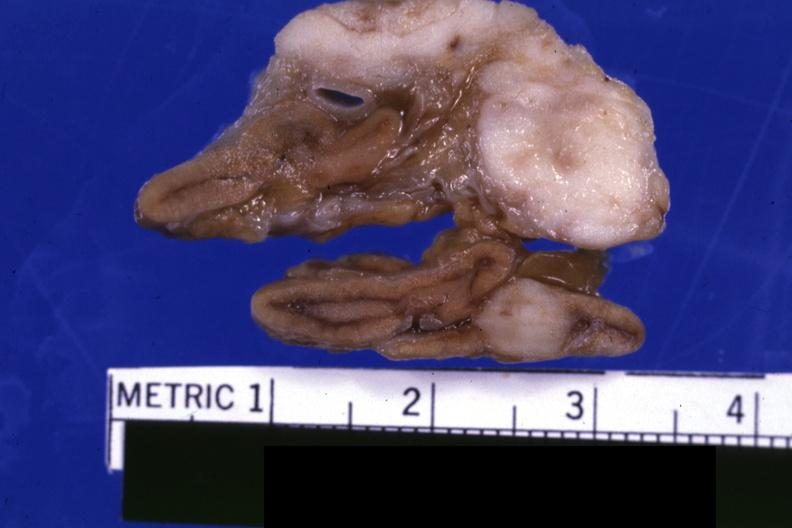what is present?
Answer the question using a single word or phrase. Adrenal 